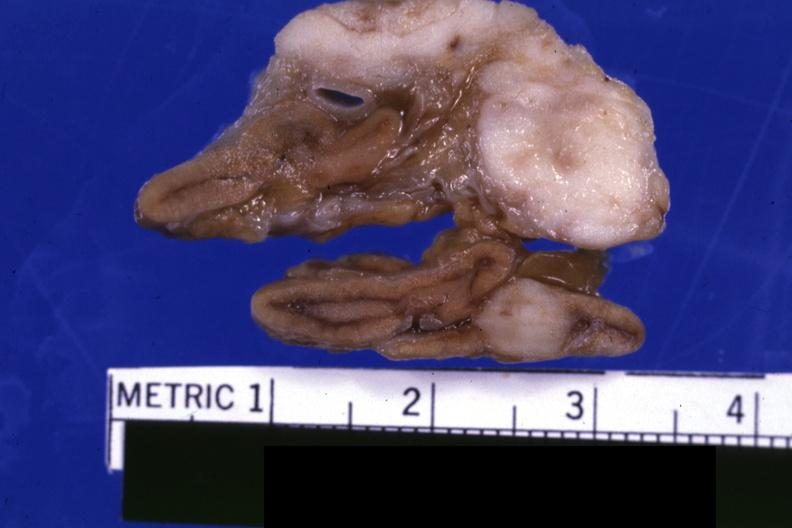what is present?
Answer the question using a single word or phrase. Adrenal 